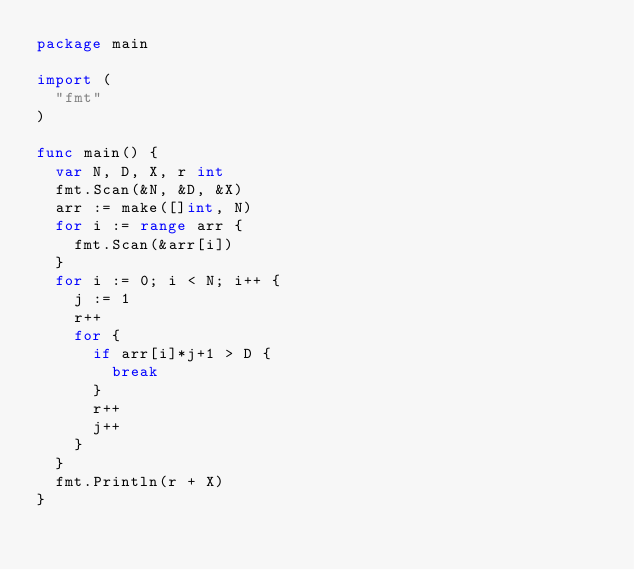<code> <loc_0><loc_0><loc_500><loc_500><_Go_>package main

import (
	"fmt"
)

func main() {
	var N, D, X, r int
	fmt.Scan(&N, &D, &X)
	arr := make([]int, N)
	for i := range arr {
		fmt.Scan(&arr[i])
	}
	for i := 0; i < N; i++ {
		j := 1
		r++
		for {
			if arr[i]*j+1 > D {
				break
			}
			r++
			j++
		}
	}
	fmt.Println(r + X)
}</code> 